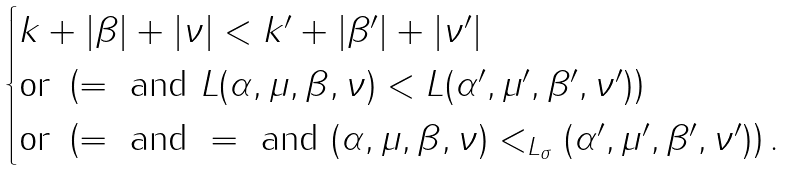Convert formula to latex. <formula><loc_0><loc_0><loc_500><loc_500>\begin{cases} k + | \beta | + | \nu | < k ^ { \prime } + | \beta ^ { \prime } | + | \nu ^ { \prime } | \\ \text {or } \left ( = \text { and } L ( \alpha , \mu , \beta , \nu ) < L ( \alpha ^ { \prime } , \mu ^ { \prime } , \beta ^ { \prime } , \nu ^ { \prime } ) \right ) \\ \text {or } \left ( = \text { and } = \text { and } ( \alpha , \mu , \beta , \nu ) < _ { L _ { \sigma } } ( \alpha ^ { \prime } , \mu ^ { \prime } , \beta ^ { \prime } , \nu ^ { \prime } ) \right ) . \end{cases}</formula> 